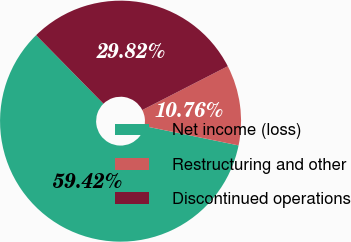Convert chart to OTSL. <chart><loc_0><loc_0><loc_500><loc_500><pie_chart><fcel>Net income (loss)<fcel>Restructuring and other<fcel>Discontinued operations<nl><fcel>59.42%<fcel>10.76%<fcel>29.82%<nl></chart> 